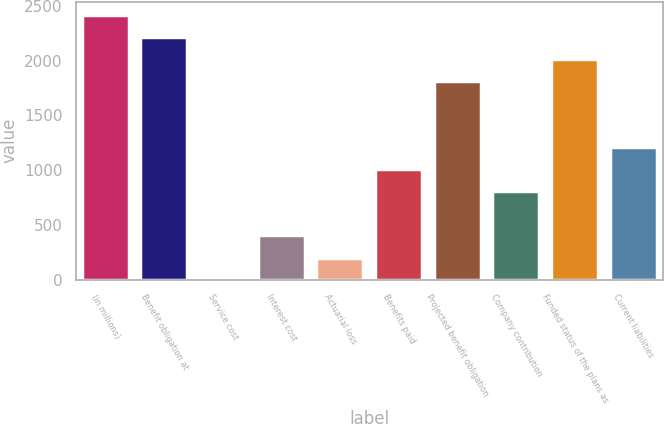Convert chart to OTSL. <chart><loc_0><loc_0><loc_500><loc_500><bar_chart><fcel>(in millions)<fcel>Benefit obligation at<fcel>Service cost<fcel>Interest cost<fcel>Actuarial loss<fcel>Benefits paid<fcel>Projected benefit obligation<fcel>Company contribution<fcel>Funded status of the plans as<fcel>Current liabilities<nl><fcel>2415.48<fcel>2214.24<fcel>0.6<fcel>403.08<fcel>201.84<fcel>1006.8<fcel>1811.76<fcel>805.56<fcel>2013<fcel>1208.04<nl></chart> 